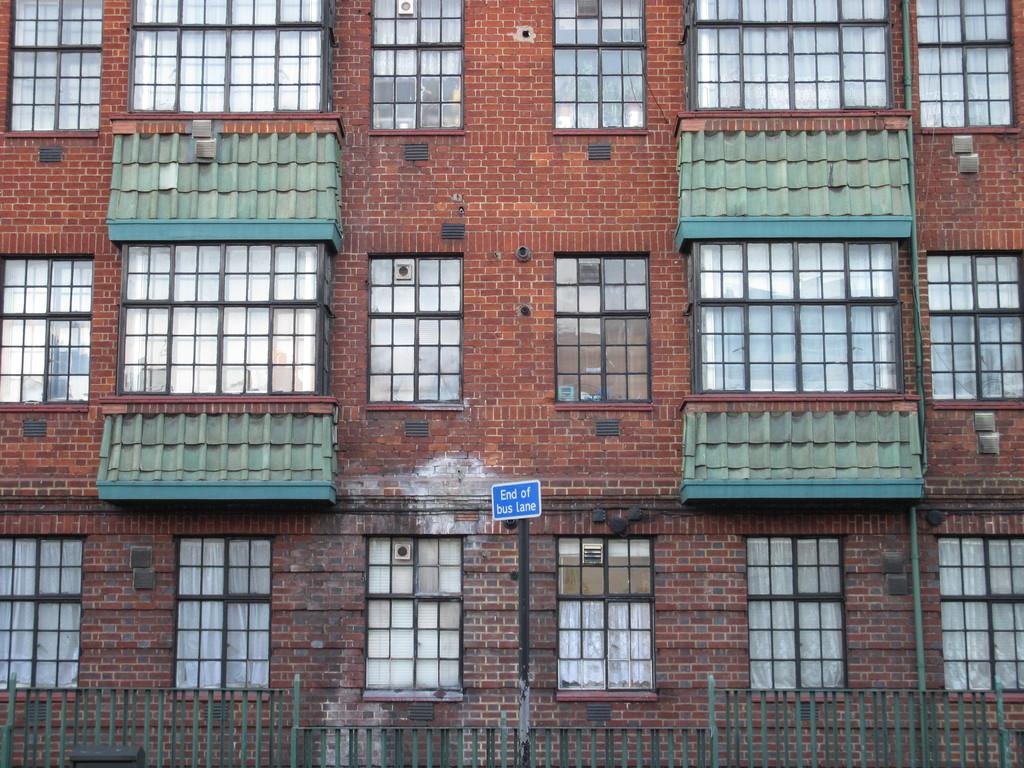What type of structures can be seen in the image? There are buildings in the image. What architectural feature is present in the image? There is fencing in the image. What type of signage is visible in the image? There is a sign board in the image. What can be used to see the outside environment from inside the buildings? There are windows in the image. How many passengers are visible in the image? There are no passengers present in the image. What type of light can be seen illuminating the buildings in the image? There is no specific light source mentioned or visible in the image. 